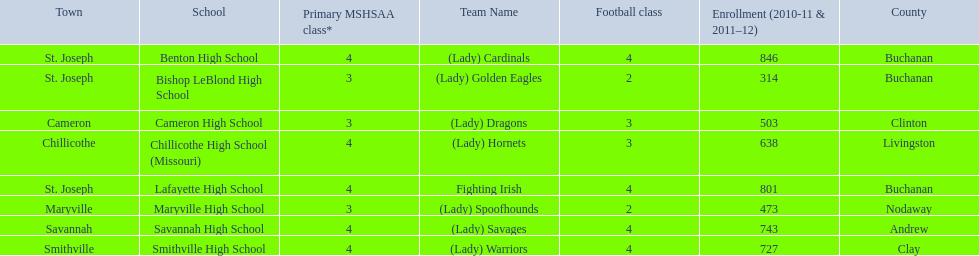What are the names of the schools? Benton High School, Bishop LeBlond High School, Cameron High School, Chillicothe High School (Missouri), Lafayette High School, Maryville High School, Savannah High School, Smithville High School. Of those, which had a total enrollment of less than 500? Bishop LeBlond High School, Maryville High School. And of those, which had the lowest enrollment? Bishop LeBlond High School. 